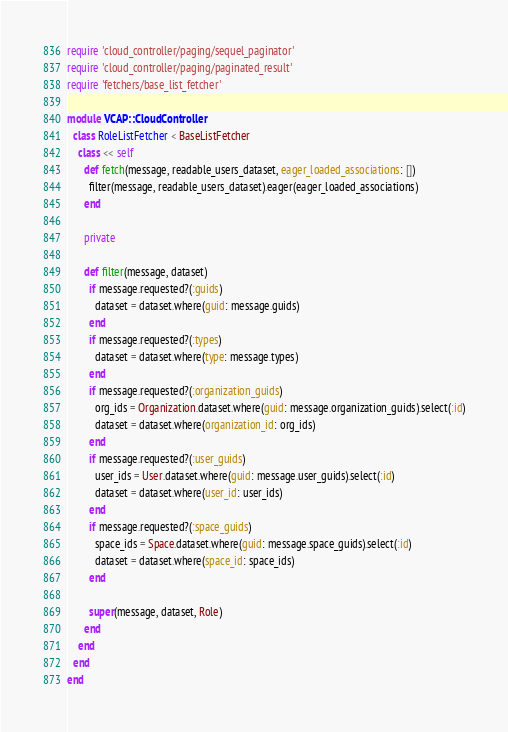<code> <loc_0><loc_0><loc_500><loc_500><_Ruby_>require 'cloud_controller/paging/sequel_paginator'
require 'cloud_controller/paging/paginated_result'
require 'fetchers/base_list_fetcher'

module VCAP::CloudController
  class RoleListFetcher < BaseListFetcher
    class << self
      def fetch(message, readable_users_dataset, eager_loaded_associations: [])
        filter(message, readable_users_dataset).eager(eager_loaded_associations)
      end

      private

      def filter(message, dataset)
        if message.requested?(:guids)
          dataset = dataset.where(guid: message.guids)
        end
        if message.requested?(:types)
          dataset = dataset.where(type: message.types)
        end
        if message.requested?(:organization_guids)
          org_ids = Organization.dataset.where(guid: message.organization_guids).select(:id)
          dataset = dataset.where(organization_id: org_ids)
        end
        if message.requested?(:user_guids)
          user_ids = User.dataset.where(guid: message.user_guids).select(:id)
          dataset = dataset.where(user_id: user_ids)
        end
        if message.requested?(:space_guids)
          space_ids = Space.dataset.where(guid: message.space_guids).select(:id)
          dataset = dataset.where(space_id: space_ids)
        end

        super(message, dataset, Role)
      end
    end
  end
end
</code> 